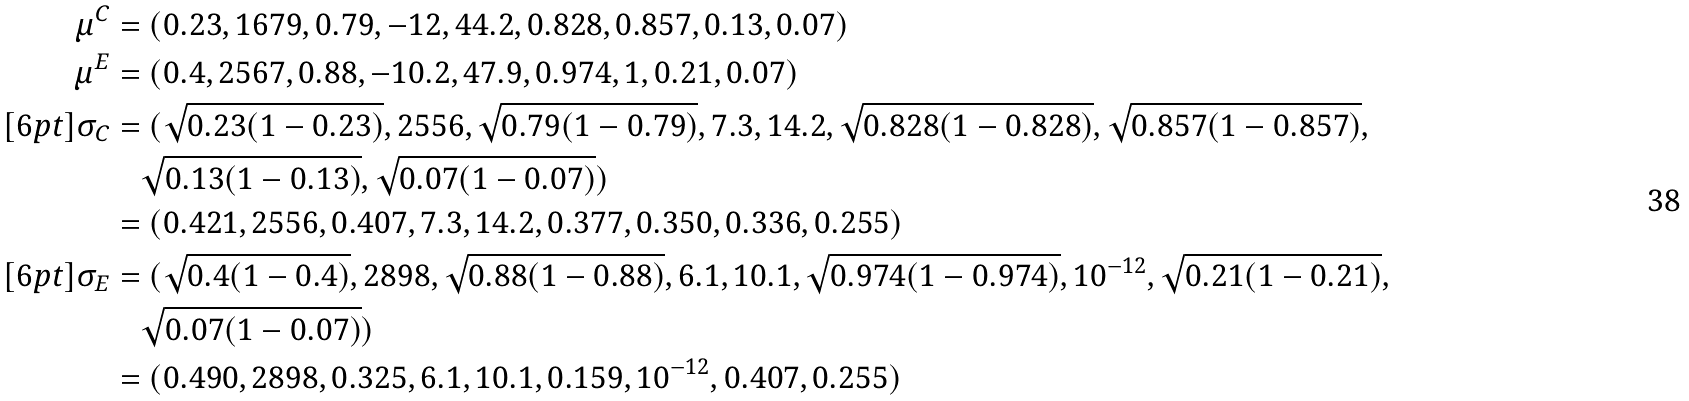Convert formula to latex. <formula><loc_0><loc_0><loc_500><loc_500>\mu ^ { C } & = ( 0 . 2 3 , 1 6 7 9 , 0 . 7 9 , - 1 2 , 4 4 . 2 , 0 . 8 2 8 , 0 . 8 5 7 , 0 . 1 3 , 0 . 0 7 ) \\ \mu ^ { E } & = ( 0 . 4 , 2 5 6 7 , 0 . 8 8 , - 1 0 . 2 , 4 7 . 9 , 0 . 9 7 4 , 1 , 0 . 2 1 , 0 . 0 7 ) \\ [ 6 p t ] \sigma _ { C } & = ( \sqrt { 0 . 2 3 ( 1 - 0 . 2 3 ) } , 2 5 5 6 , \sqrt { 0 . 7 9 ( 1 - 0 . 7 9 ) } , 7 . 3 , 1 4 . 2 , \sqrt { 0 . 8 2 8 ( 1 - 0 . 8 2 8 ) } , \sqrt { 0 . 8 5 7 ( 1 - 0 . 8 5 7 ) } , \\ & \quad \sqrt { 0 . 1 3 ( 1 - 0 . 1 3 ) } , \sqrt { 0 . 0 7 ( 1 - 0 . 0 7 ) } ) \\ & = ( 0 . 4 2 1 , 2 5 5 6 , 0 . 4 0 7 , 7 . 3 , 1 4 . 2 , 0 . 3 7 7 , 0 . 3 5 0 , 0 . 3 3 6 , 0 . 2 5 5 ) \\ [ 6 p t ] \sigma _ { E } & = ( \sqrt { 0 . 4 ( 1 - 0 . 4 ) } , 2 8 9 8 , \sqrt { 0 . 8 8 ( 1 - 0 . 8 8 ) } , 6 . 1 , 1 0 . 1 , \sqrt { 0 . 9 7 4 ( 1 - 0 . 9 7 4 ) } , 1 0 ^ { - 1 2 } , \sqrt { 0 . 2 1 ( 1 - 0 . 2 1 ) } , \\ & \quad \sqrt { 0 . 0 7 ( 1 - 0 . 0 7 ) } ) \\ & = ( 0 . 4 9 0 , 2 8 9 8 , 0 . 3 2 5 , 6 . 1 , 1 0 . 1 , 0 . 1 5 9 , 1 0 ^ { - 1 2 } , 0 . 4 0 7 , 0 . 2 5 5 )</formula> 